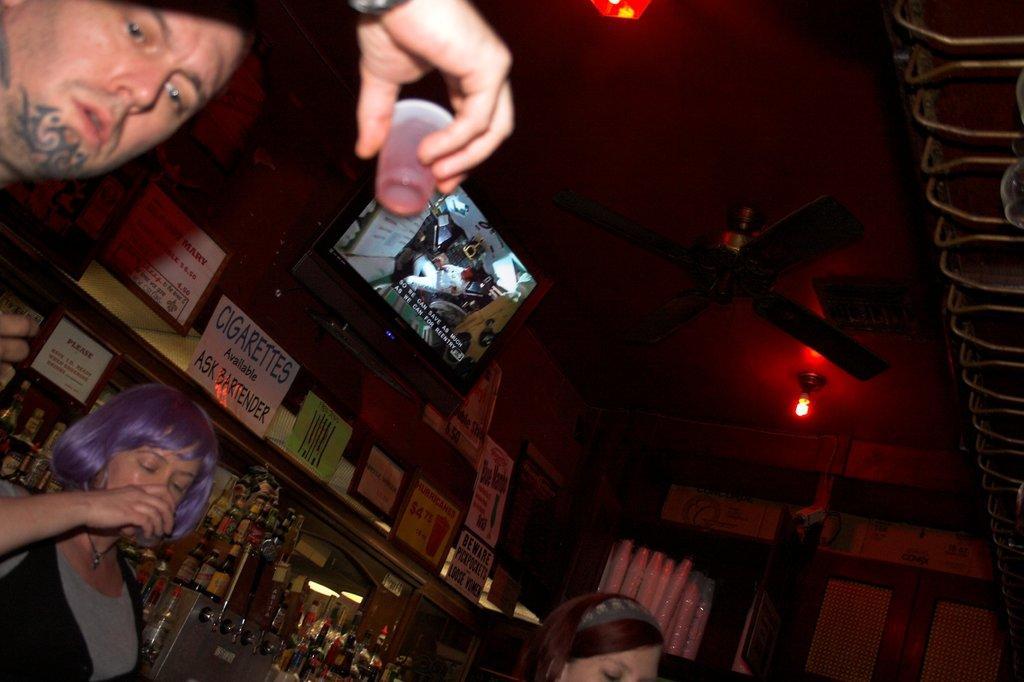How would you summarize this image in a sentence or two? In this image, there are a few people. We can see some boards with text and images. We can see a screen and a fan. We can see the roof with some objects attached to it. We can also see a shelf with some white colored objects. We can see some objects on the right. We can also see some bottles and a metal object. We can also see some glass. 